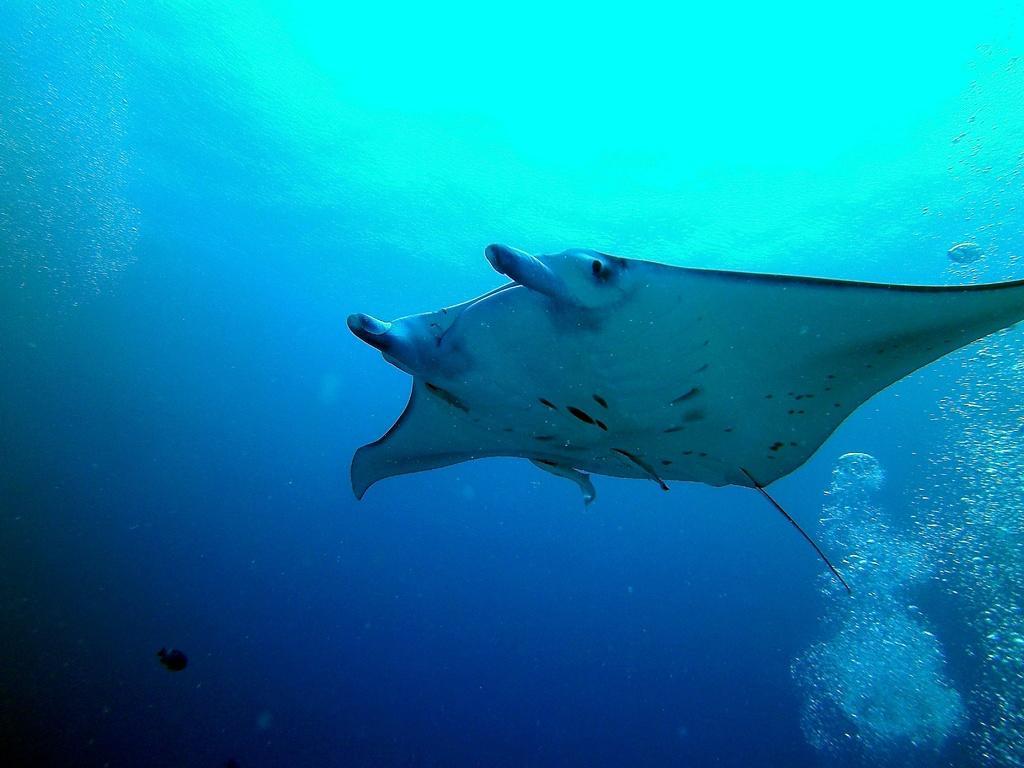Can you describe this image briefly? In this image I can see the picture inside the water in which I can see a aquatic animal which is white and black in color and few air bubbles in the background. 